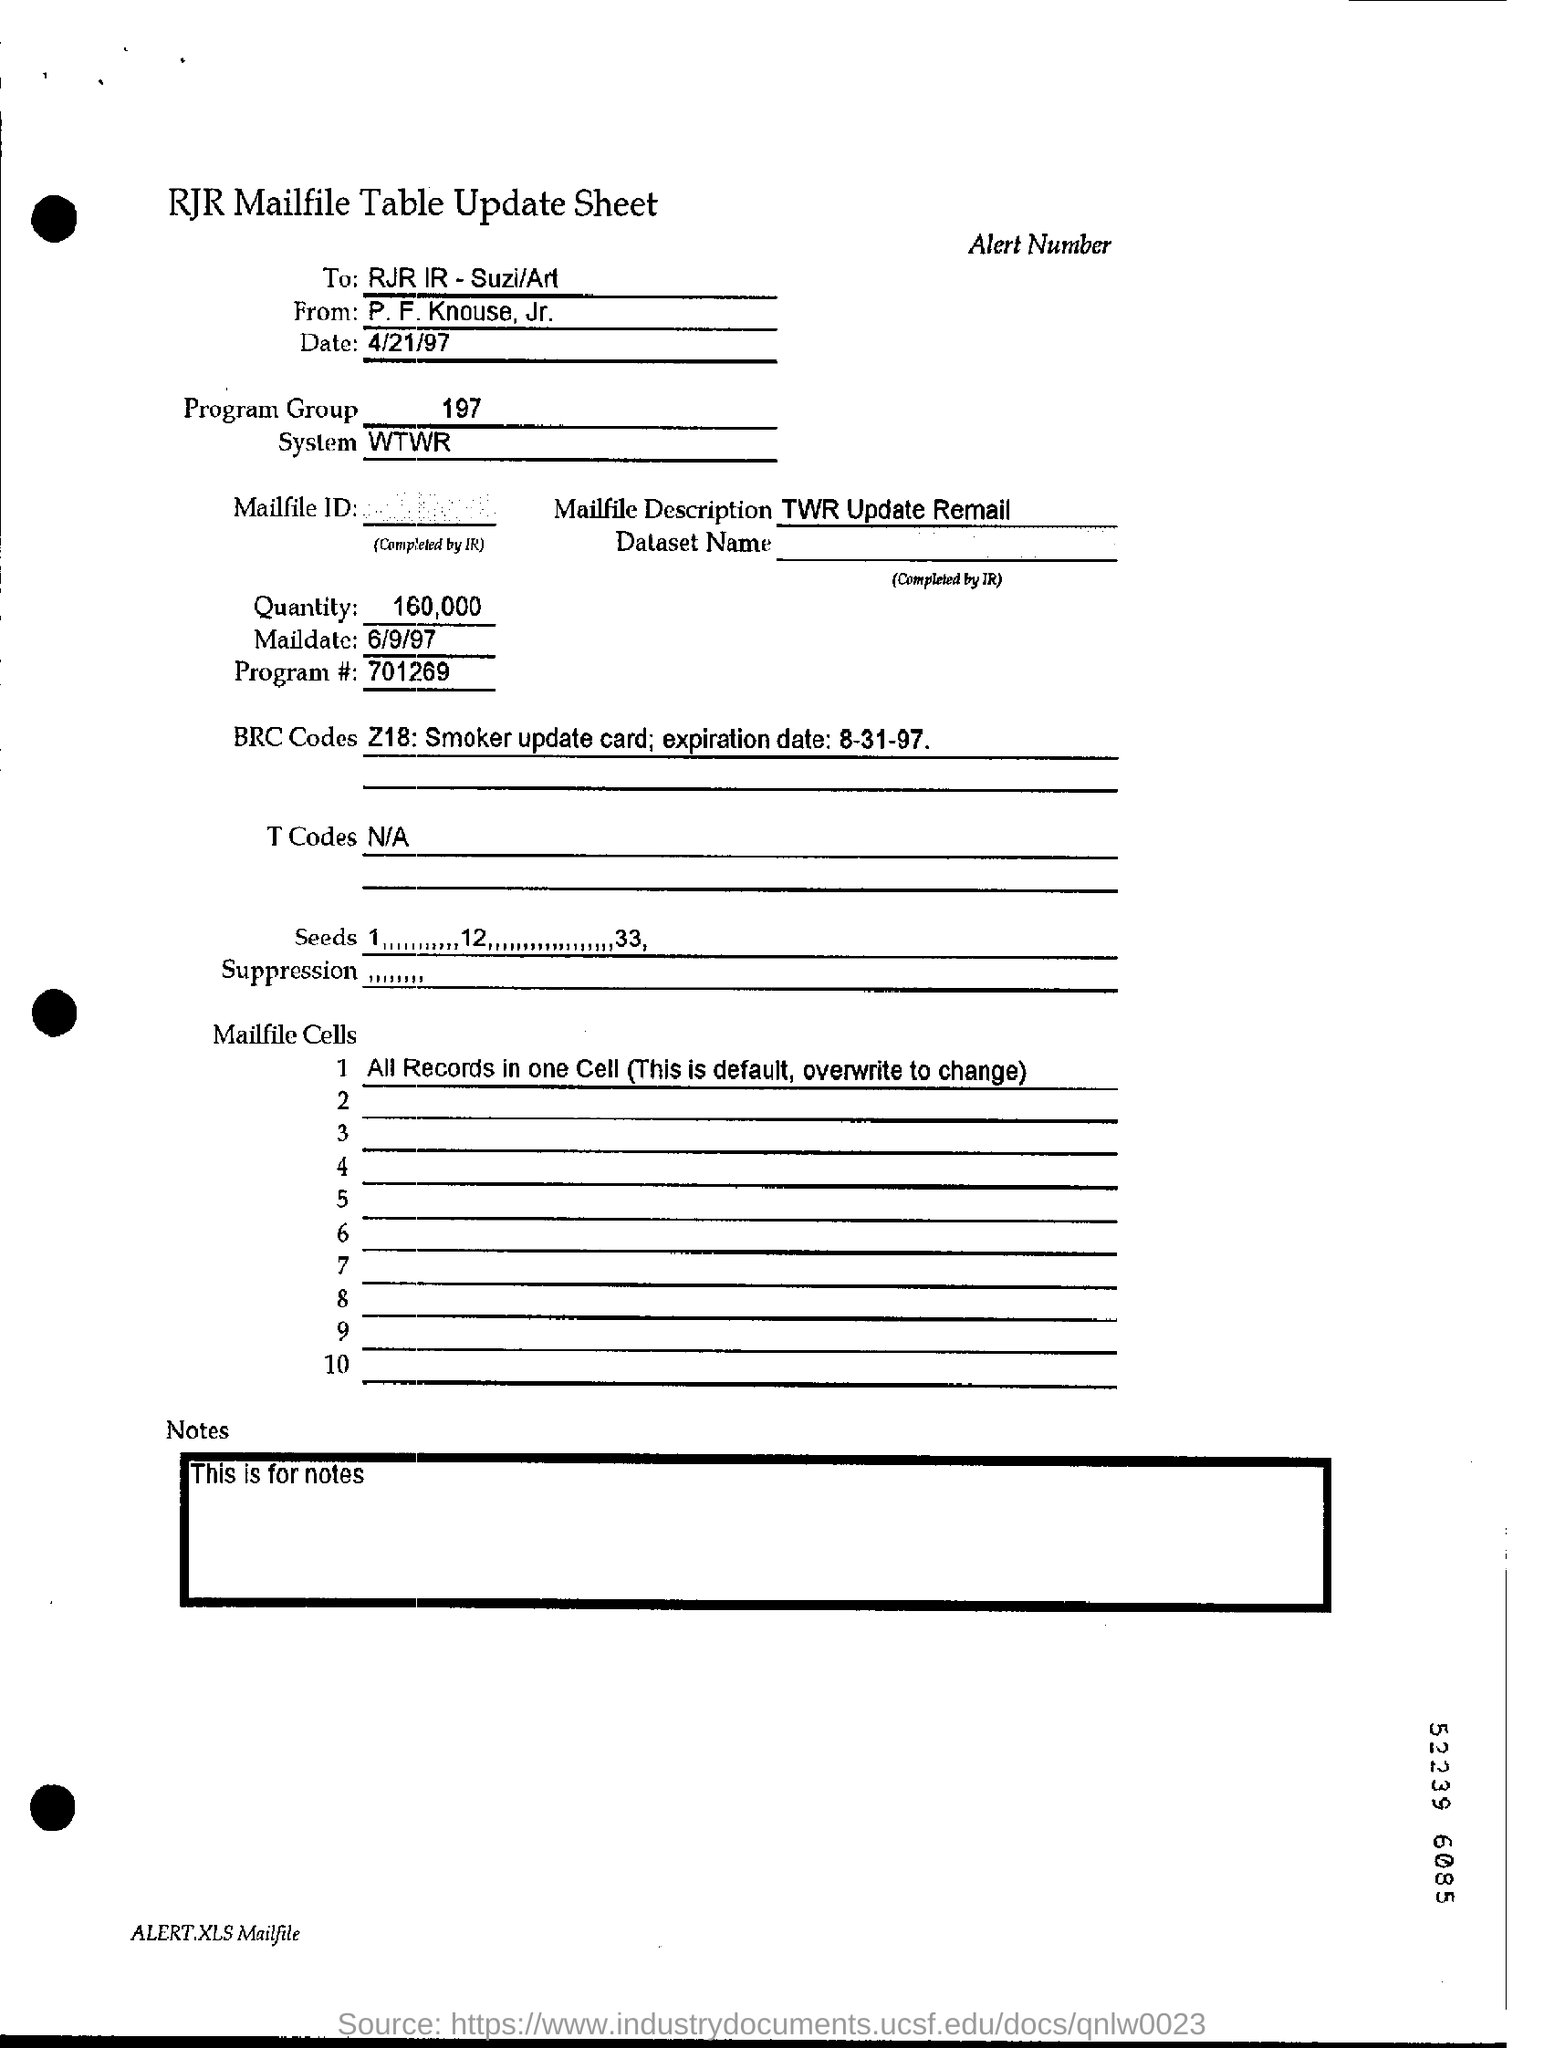What is the program group specified?
Make the answer very short. 197. What is the mailfile description?
Provide a short and direct response. TWR Update Remail. What is the quantity mentioned?
Your answer should be very brief. 160,000. When is the mail date?
Ensure brevity in your answer.  6/9/97. What is the program number?
Provide a short and direct response. 701269. 